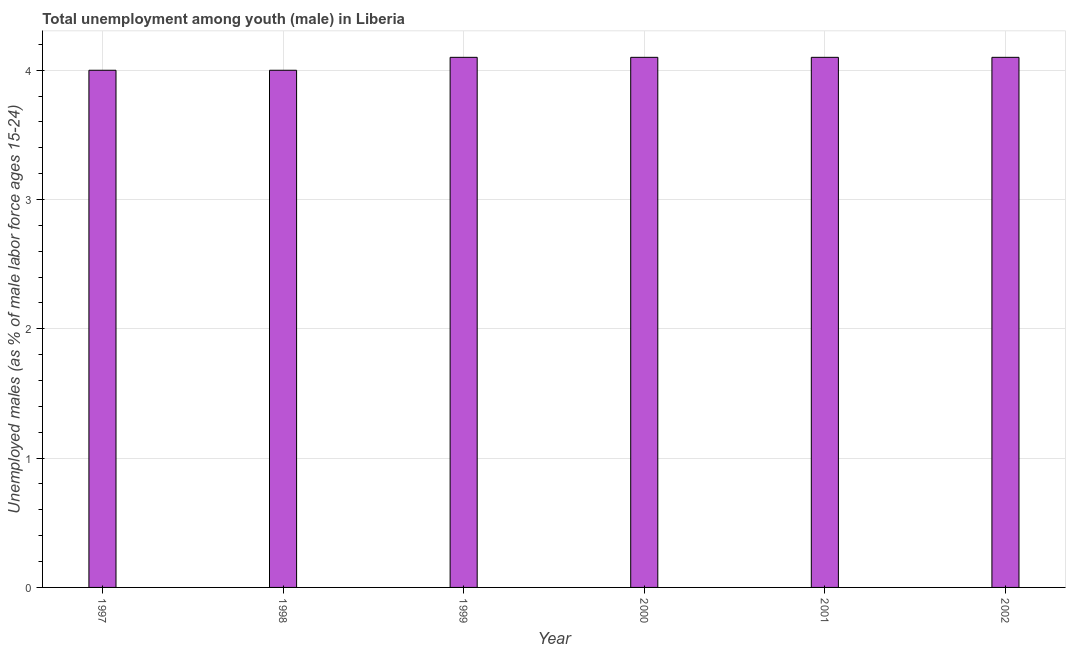Does the graph contain any zero values?
Offer a terse response. No. Does the graph contain grids?
Your answer should be very brief. Yes. What is the title of the graph?
Your answer should be very brief. Total unemployment among youth (male) in Liberia. What is the label or title of the Y-axis?
Ensure brevity in your answer.  Unemployed males (as % of male labor force ages 15-24). Across all years, what is the maximum unemployed male youth population?
Provide a succinct answer. 4.1. What is the sum of the unemployed male youth population?
Your response must be concise. 24.4. What is the average unemployed male youth population per year?
Make the answer very short. 4.07. What is the median unemployed male youth population?
Provide a succinct answer. 4.1. Do a majority of the years between 2001 and 1997 (inclusive) have unemployed male youth population greater than 4 %?
Ensure brevity in your answer.  Yes. What is the ratio of the unemployed male youth population in 1997 to that in 1998?
Offer a very short reply. 1. Is the unemployed male youth population in 1997 less than that in 2000?
Your answer should be compact. Yes. Is the difference between the unemployed male youth population in 1998 and 2000 greater than the difference between any two years?
Your answer should be compact. Yes. What is the difference between the highest and the second highest unemployed male youth population?
Provide a short and direct response. 0. Is the sum of the unemployed male youth population in 1998 and 2000 greater than the maximum unemployed male youth population across all years?
Provide a succinct answer. Yes. What is the difference between the highest and the lowest unemployed male youth population?
Make the answer very short. 0.1. Are the values on the major ticks of Y-axis written in scientific E-notation?
Make the answer very short. No. What is the Unemployed males (as % of male labor force ages 15-24) in 1997?
Give a very brief answer. 4. What is the Unemployed males (as % of male labor force ages 15-24) in 1999?
Offer a terse response. 4.1. What is the Unemployed males (as % of male labor force ages 15-24) in 2000?
Offer a terse response. 4.1. What is the Unemployed males (as % of male labor force ages 15-24) in 2001?
Your answer should be compact. 4.1. What is the Unemployed males (as % of male labor force ages 15-24) in 2002?
Ensure brevity in your answer.  4.1. What is the difference between the Unemployed males (as % of male labor force ages 15-24) in 1997 and 1998?
Offer a very short reply. 0. What is the difference between the Unemployed males (as % of male labor force ages 15-24) in 1997 and 1999?
Offer a very short reply. -0.1. What is the difference between the Unemployed males (as % of male labor force ages 15-24) in 1997 and 2000?
Your response must be concise. -0.1. What is the difference between the Unemployed males (as % of male labor force ages 15-24) in 1999 and 2000?
Offer a terse response. 0. What is the difference between the Unemployed males (as % of male labor force ages 15-24) in 1999 and 2001?
Make the answer very short. 0. What is the difference between the Unemployed males (as % of male labor force ages 15-24) in 1999 and 2002?
Your answer should be compact. 0. What is the difference between the Unemployed males (as % of male labor force ages 15-24) in 2000 and 2001?
Your answer should be very brief. 0. What is the ratio of the Unemployed males (as % of male labor force ages 15-24) in 1997 to that in 1999?
Provide a succinct answer. 0.98. What is the ratio of the Unemployed males (as % of male labor force ages 15-24) in 1997 to that in 2001?
Your answer should be compact. 0.98. What is the ratio of the Unemployed males (as % of male labor force ages 15-24) in 1998 to that in 1999?
Your answer should be compact. 0.98. What is the ratio of the Unemployed males (as % of male labor force ages 15-24) in 1998 to that in 2000?
Your response must be concise. 0.98. What is the ratio of the Unemployed males (as % of male labor force ages 15-24) in 1998 to that in 2002?
Ensure brevity in your answer.  0.98. What is the ratio of the Unemployed males (as % of male labor force ages 15-24) in 1999 to that in 2000?
Provide a short and direct response. 1. What is the ratio of the Unemployed males (as % of male labor force ages 15-24) in 1999 to that in 2001?
Your answer should be very brief. 1. What is the ratio of the Unemployed males (as % of male labor force ages 15-24) in 1999 to that in 2002?
Keep it short and to the point. 1. What is the ratio of the Unemployed males (as % of male labor force ages 15-24) in 2000 to that in 2001?
Offer a very short reply. 1. What is the ratio of the Unemployed males (as % of male labor force ages 15-24) in 2001 to that in 2002?
Offer a terse response. 1. 